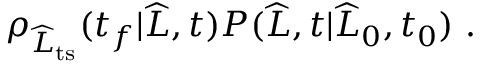<formula> <loc_0><loc_0><loc_500><loc_500>\begin{array} { r } { \rho _ { \widehat { L } _ { t s } } ( t _ { f } | \widehat { L } , t ) P ( \widehat { L } , t | \widehat { L } _ { 0 } , t _ { 0 } ) \ . } \end{array}</formula> 